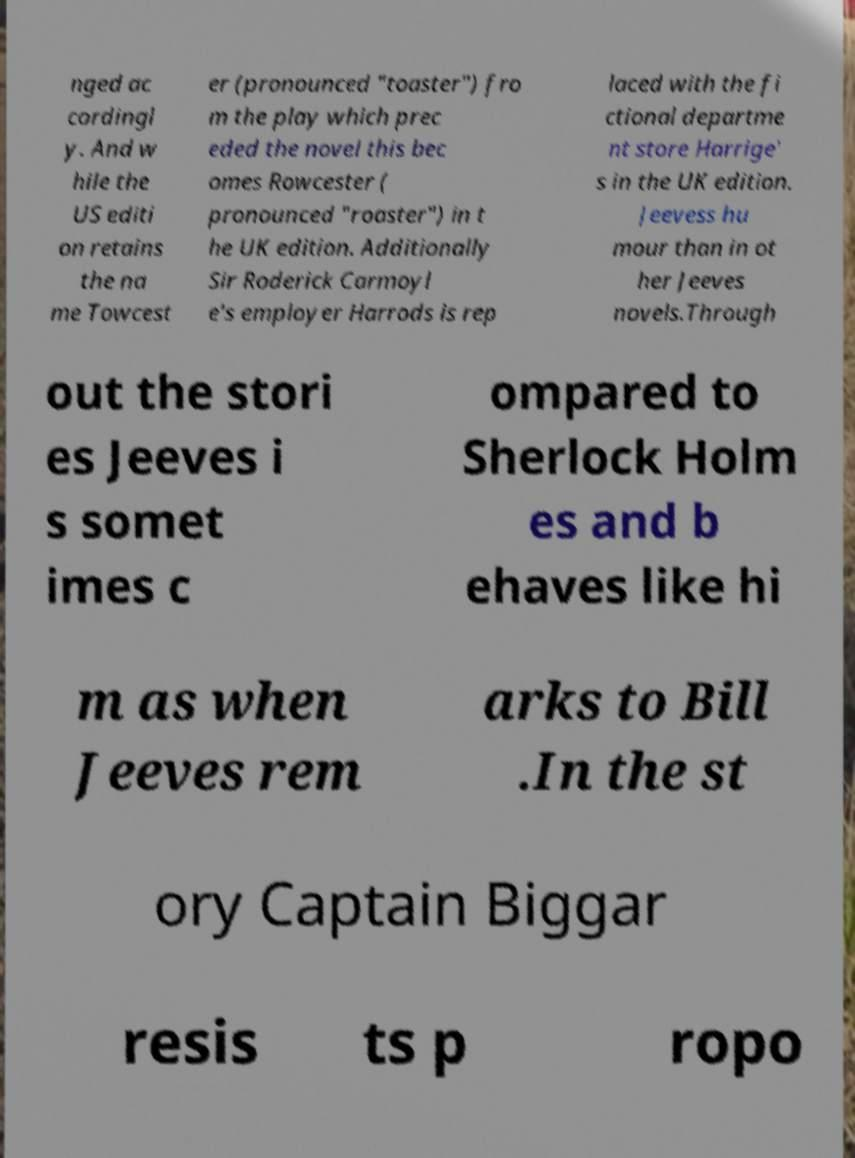Can you read and provide the text displayed in the image?This photo seems to have some interesting text. Can you extract and type it out for me? nged ac cordingl y. And w hile the US editi on retains the na me Towcest er (pronounced "toaster") fro m the play which prec eded the novel this bec omes Rowcester ( pronounced "roaster") in t he UK edition. Additionally Sir Roderick Carmoyl e's employer Harrods is rep laced with the fi ctional departme nt store Harrige' s in the UK edition. Jeevess hu mour than in ot her Jeeves novels.Through out the stori es Jeeves i s somet imes c ompared to Sherlock Holm es and b ehaves like hi m as when Jeeves rem arks to Bill .In the st ory Captain Biggar resis ts p ropo 